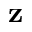Convert formula to latex. <formula><loc_0><loc_0><loc_500><loc_500>z</formula> 